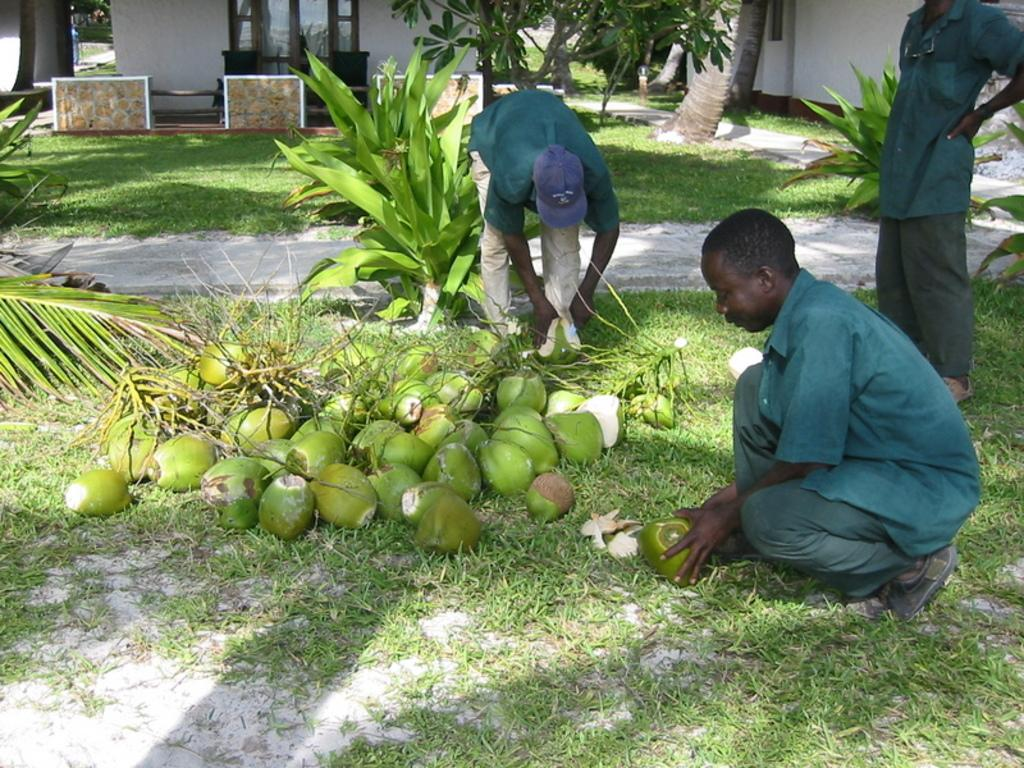How many persons can be seen in the image? There are persons in the image. What is present on the ground near the persons? There are coconuts on the ground. What can be seen in the background of the image? There are buildings, bushes, trees, and sand visible in the background of the image. Where is the goose getting its haircut in the image? There is no goose or haircut present in the image. 